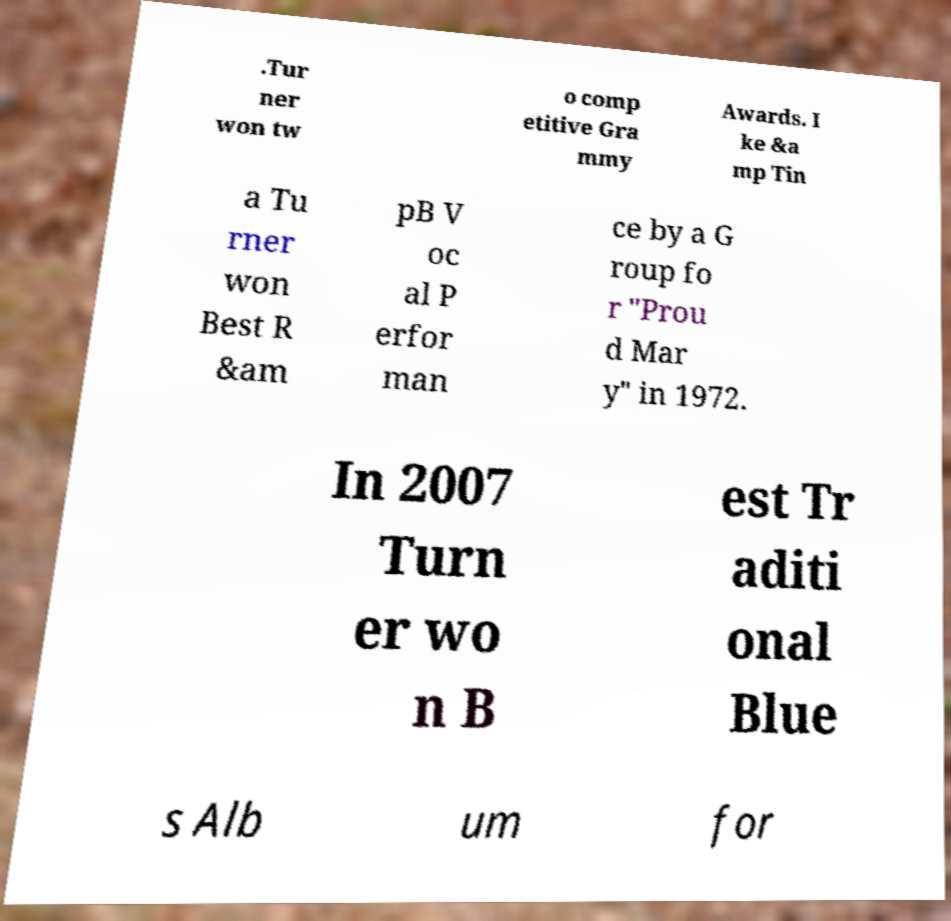For documentation purposes, I need the text within this image transcribed. Could you provide that? .Tur ner won tw o comp etitive Gra mmy Awards. I ke &a mp Tin a Tu rner won Best R &am pB V oc al P erfor man ce by a G roup fo r "Prou d Mar y" in 1972. In 2007 Turn er wo n B est Tr aditi onal Blue s Alb um for 